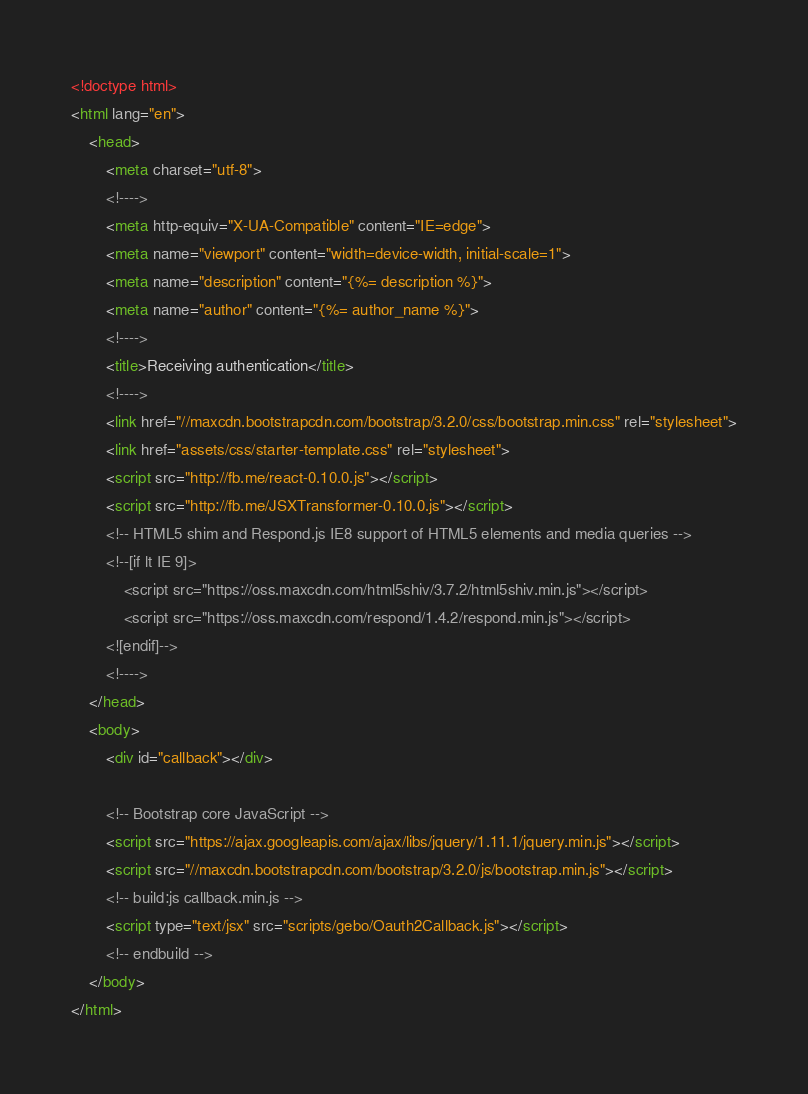<code> <loc_0><loc_0><loc_500><loc_500><_HTML_><!doctype html>
<html lang="en">
    <head>
        <meta charset="utf-8">
        <!---->
        <meta http-equiv="X-UA-Compatible" content="IE=edge">
        <meta name="viewport" content="width=device-width, initial-scale=1">
        <meta name="description" content="{%= description %}">
        <meta name="author" content="{%= author_name %}">
        <!---->
        <title>Receiving authentication</title>
        <!---->
        <link href="//maxcdn.bootstrapcdn.com/bootstrap/3.2.0/css/bootstrap.min.css" rel="stylesheet">
        <link href="assets/css/starter-template.css" rel="stylesheet">
        <script src="http://fb.me/react-0.10.0.js"></script>
        <script src="http://fb.me/JSXTransformer-0.10.0.js"></script>
        <!-- HTML5 shim and Respond.js IE8 support of HTML5 elements and media queries -->
        <!--[if lt IE 9]>
            <script src="https://oss.maxcdn.com/html5shiv/3.7.2/html5shiv.min.js"></script>
            <script src="https://oss.maxcdn.com/respond/1.4.2/respond.min.js"></script>
        <![endif]-->
        <!---->
    </head>
    <body>
        <div id="callback"></div>
 
        <!-- Bootstrap core JavaScript -->
        <script src="https://ajax.googleapis.com/ajax/libs/jquery/1.11.1/jquery.min.js"></script>
        <script src="//maxcdn.bootstrapcdn.com/bootstrap/3.2.0/js/bootstrap.min.js"></script>
        <!-- build:js callback.min.js --> 
        <script type="text/jsx" src="scripts/gebo/Oauth2Callback.js"></script>
        <!-- endbuild -->
    </body>
</html>
</code> 